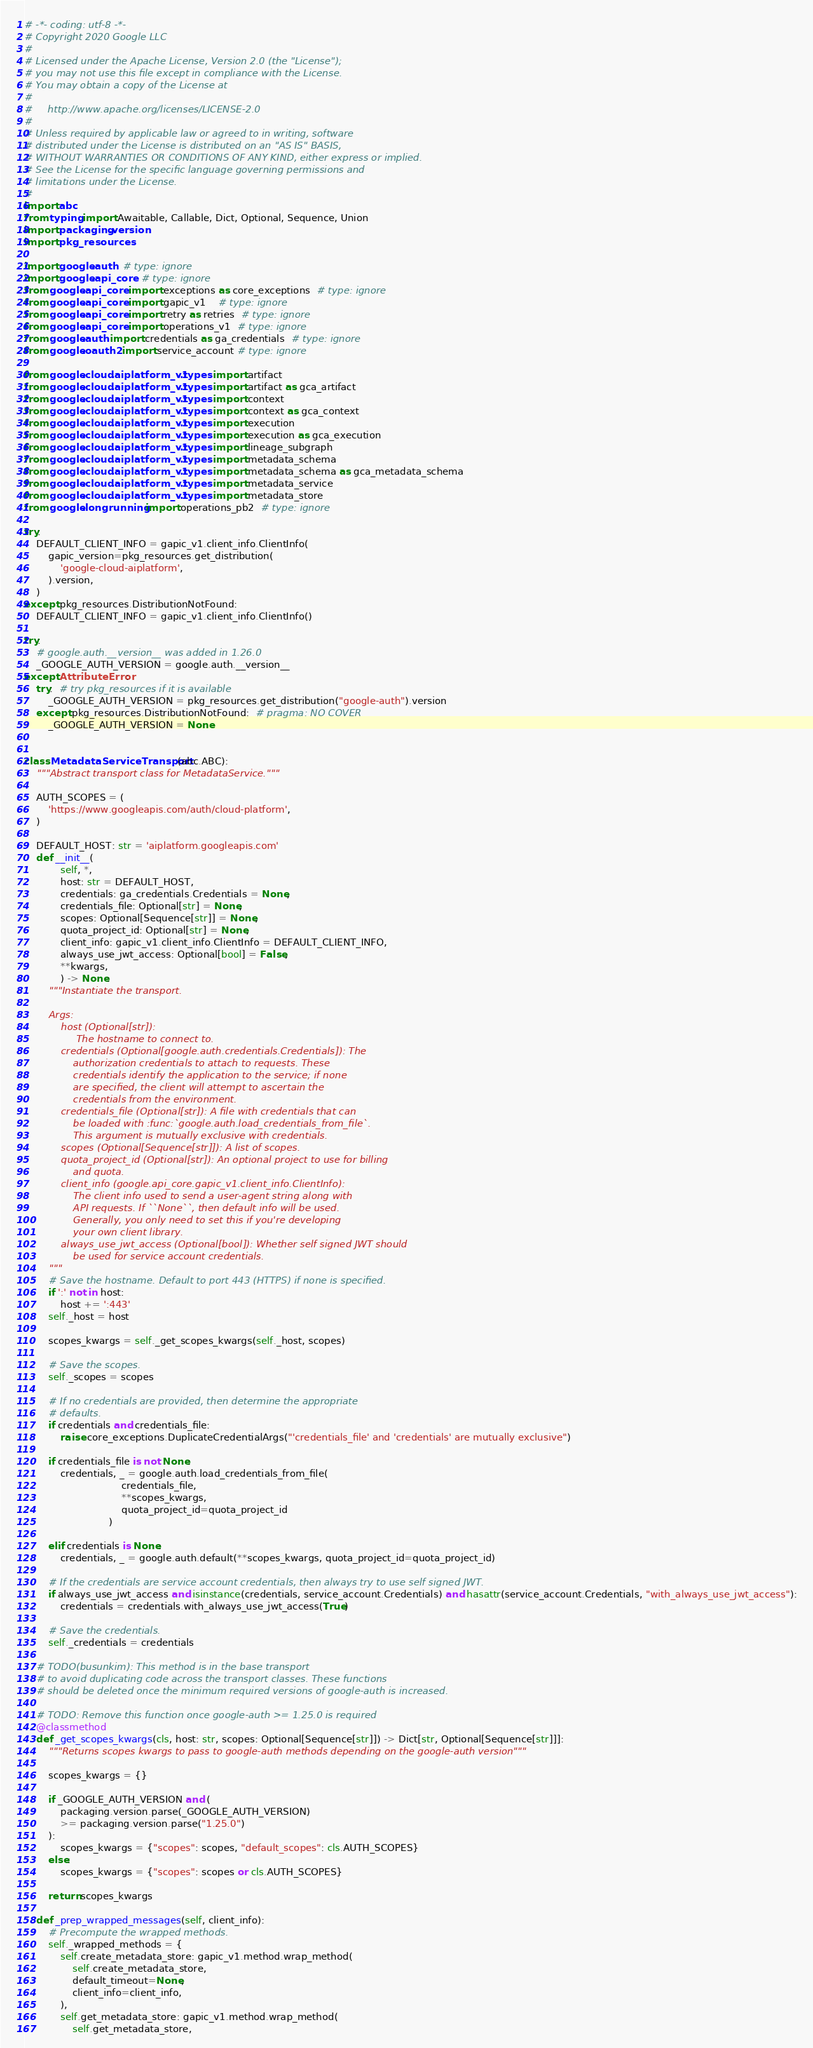Convert code to text. <code><loc_0><loc_0><loc_500><loc_500><_Python_># -*- coding: utf-8 -*-
# Copyright 2020 Google LLC
#
# Licensed under the Apache License, Version 2.0 (the "License");
# you may not use this file except in compliance with the License.
# You may obtain a copy of the License at
#
#     http://www.apache.org/licenses/LICENSE-2.0
#
# Unless required by applicable law or agreed to in writing, software
# distributed under the License is distributed on an "AS IS" BASIS,
# WITHOUT WARRANTIES OR CONDITIONS OF ANY KIND, either express or implied.
# See the License for the specific language governing permissions and
# limitations under the License.
#
import abc
from typing import Awaitable, Callable, Dict, Optional, Sequence, Union
import packaging.version
import pkg_resources

import google.auth  # type: ignore
import google.api_core  # type: ignore
from google.api_core import exceptions as core_exceptions  # type: ignore
from google.api_core import gapic_v1    # type: ignore
from google.api_core import retry as retries  # type: ignore
from google.api_core import operations_v1  # type: ignore
from google.auth import credentials as ga_credentials  # type: ignore
from google.oauth2 import service_account # type: ignore

from google.cloud.aiplatform_v1.types import artifact
from google.cloud.aiplatform_v1.types import artifact as gca_artifact
from google.cloud.aiplatform_v1.types import context
from google.cloud.aiplatform_v1.types import context as gca_context
from google.cloud.aiplatform_v1.types import execution
from google.cloud.aiplatform_v1.types import execution as gca_execution
from google.cloud.aiplatform_v1.types import lineage_subgraph
from google.cloud.aiplatform_v1.types import metadata_schema
from google.cloud.aiplatform_v1.types import metadata_schema as gca_metadata_schema
from google.cloud.aiplatform_v1.types import metadata_service
from google.cloud.aiplatform_v1.types import metadata_store
from google.longrunning import operations_pb2  # type: ignore

try:
    DEFAULT_CLIENT_INFO = gapic_v1.client_info.ClientInfo(
        gapic_version=pkg_resources.get_distribution(
            'google-cloud-aiplatform',
        ).version,
    )
except pkg_resources.DistributionNotFound:
    DEFAULT_CLIENT_INFO = gapic_v1.client_info.ClientInfo()

try:
    # google.auth.__version__ was added in 1.26.0
    _GOOGLE_AUTH_VERSION = google.auth.__version__
except AttributeError:
    try:  # try pkg_resources if it is available
        _GOOGLE_AUTH_VERSION = pkg_resources.get_distribution("google-auth").version
    except pkg_resources.DistributionNotFound:  # pragma: NO COVER
        _GOOGLE_AUTH_VERSION = None


class MetadataServiceTransport(abc.ABC):
    """Abstract transport class for MetadataService."""

    AUTH_SCOPES = (
        'https://www.googleapis.com/auth/cloud-platform',
    )

    DEFAULT_HOST: str = 'aiplatform.googleapis.com'
    def __init__(
            self, *,
            host: str = DEFAULT_HOST,
            credentials: ga_credentials.Credentials = None,
            credentials_file: Optional[str] = None,
            scopes: Optional[Sequence[str]] = None,
            quota_project_id: Optional[str] = None,
            client_info: gapic_v1.client_info.ClientInfo = DEFAULT_CLIENT_INFO,
            always_use_jwt_access: Optional[bool] = False,
            **kwargs,
            ) -> None:
        """Instantiate the transport.

        Args:
            host (Optional[str]):
                 The hostname to connect to.
            credentials (Optional[google.auth.credentials.Credentials]): The
                authorization credentials to attach to requests. These
                credentials identify the application to the service; if none
                are specified, the client will attempt to ascertain the
                credentials from the environment.
            credentials_file (Optional[str]): A file with credentials that can
                be loaded with :func:`google.auth.load_credentials_from_file`.
                This argument is mutually exclusive with credentials.
            scopes (Optional[Sequence[str]]): A list of scopes.
            quota_project_id (Optional[str]): An optional project to use for billing
                and quota.
            client_info (google.api_core.gapic_v1.client_info.ClientInfo):
                The client info used to send a user-agent string along with
                API requests. If ``None``, then default info will be used.
                Generally, you only need to set this if you're developing
                your own client library.
            always_use_jwt_access (Optional[bool]): Whether self signed JWT should
                be used for service account credentials.
        """
        # Save the hostname. Default to port 443 (HTTPS) if none is specified.
        if ':' not in host:
            host += ':443'
        self._host = host

        scopes_kwargs = self._get_scopes_kwargs(self._host, scopes)

        # Save the scopes.
        self._scopes = scopes

        # If no credentials are provided, then determine the appropriate
        # defaults.
        if credentials and credentials_file:
            raise core_exceptions.DuplicateCredentialArgs("'credentials_file' and 'credentials' are mutually exclusive")

        if credentials_file is not None:
            credentials, _ = google.auth.load_credentials_from_file(
                                credentials_file,
                                **scopes_kwargs,
                                quota_project_id=quota_project_id
                            )

        elif credentials is None:
            credentials, _ = google.auth.default(**scopes_kwargs, quota_project_id=quota_project_id)

        # If the credentials are service account credentials, then always try to use self signed JWT.
        if always_use_jwt_access and isinstance(credentials, service_account.Credentials) and hasattr(service_account.Credentials, "with_always_use_jwt_access"):
            credentials = credentials.with_always_use_jwt_access(True)

        # Save the credentials.
        self._credentials = credentials

    # TODO(busunkim): This method is in the base transport
    # to avoid duplicating code across the transport classes. These functions
    # should be deleted once the minimum required versions of google-auth is increased.

    # TODO: Remove this function once google-auth >= 1.25.0 is required
    @classmethod
    def _get_scopes_kwargs(cls, host: str, scopes: Optional[Sequence[str]]) -> Dict[str, Optional[Sequence[str]]]:
        """Returns scopes kwargs to pass to google-auth methods depending on the google-auth version"""

        scopes_kwargs = {}

        if _GOOGLE_AUTH_VERSION and (
            packaging.version.parse(_GOOGLE_AUTH_VERSION)
            >= packaging.version.parse("1.25.0")
        ):
            scopes_kwargs = {"scopes": scopes, "default_scopes": cls.AUTH_SCOPES}
        else:
            scopes_kwargs = {"scopes": scopes or cls.AUTH_SCOPES}

        return scopes_kwargs

    def _prep_wrapped_messages(self, client_info):
        # Precompute the wrapped methods.
        self._wrapped_methods = {
            self.create_metadata_store: gapic_v1.method.wrap_method(
                self.create_metadata_store,
                default_timeout=None,
                client_info=client_info,
            ),
            self.get_metadata_store: gapic_v1.method.wrap_method(
                self.get_metadata_store,</code> 